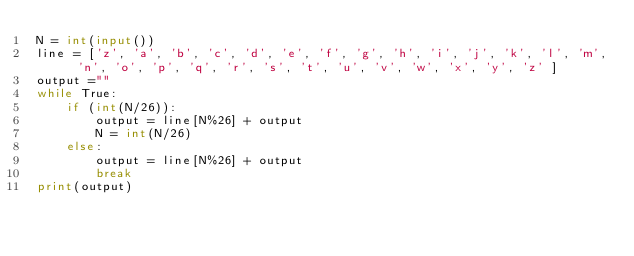<code> <loc_0><loc_0><loc_500><loc_500><_Python_>N = int(input())
line = ['z', 'a', 'b', 'c', 'd', 'e', 'f', 'g', 'h', 'i', 'j', 'k', 'l', 'm', 'n', 'o', 'p', 'q', 'r', 's', 't', 'u', 'v', 'w', 'x', 'y', 'z' ]
output =""
while True:
    if (int(N/26)):
        output = line[N%26] + output
        N = int(N/26)
    else:
        output = line[N%26] + output
        break
print(output)</code> 